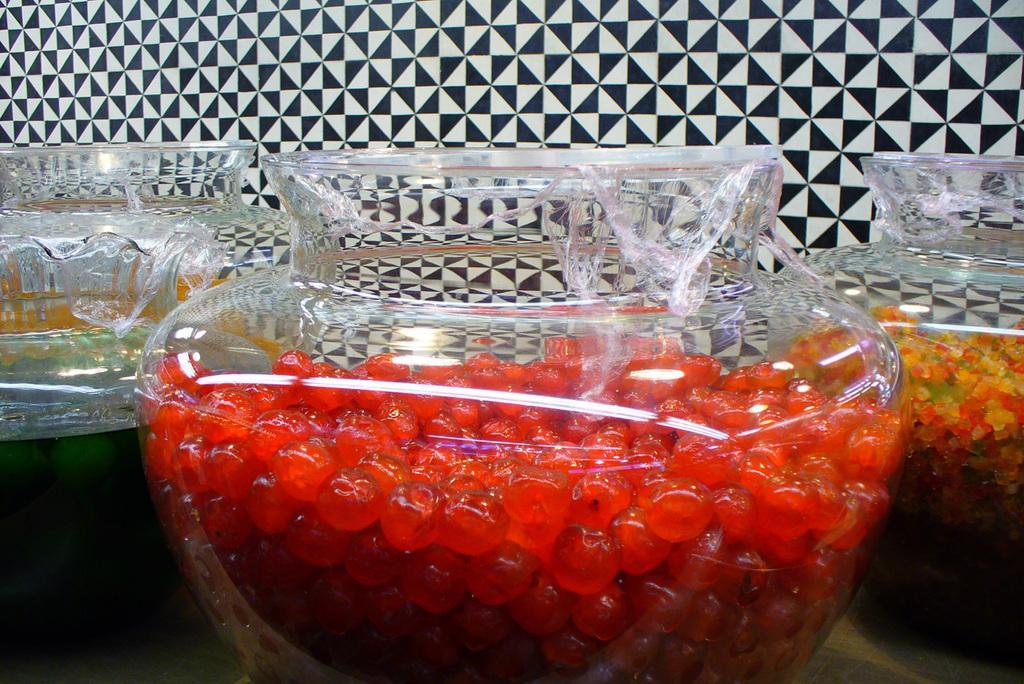Describe this image in one or two sentences. In this image, we can see a glass bowl with some eatable things. At the bottom, there is a surface. Background we can see a wall. 